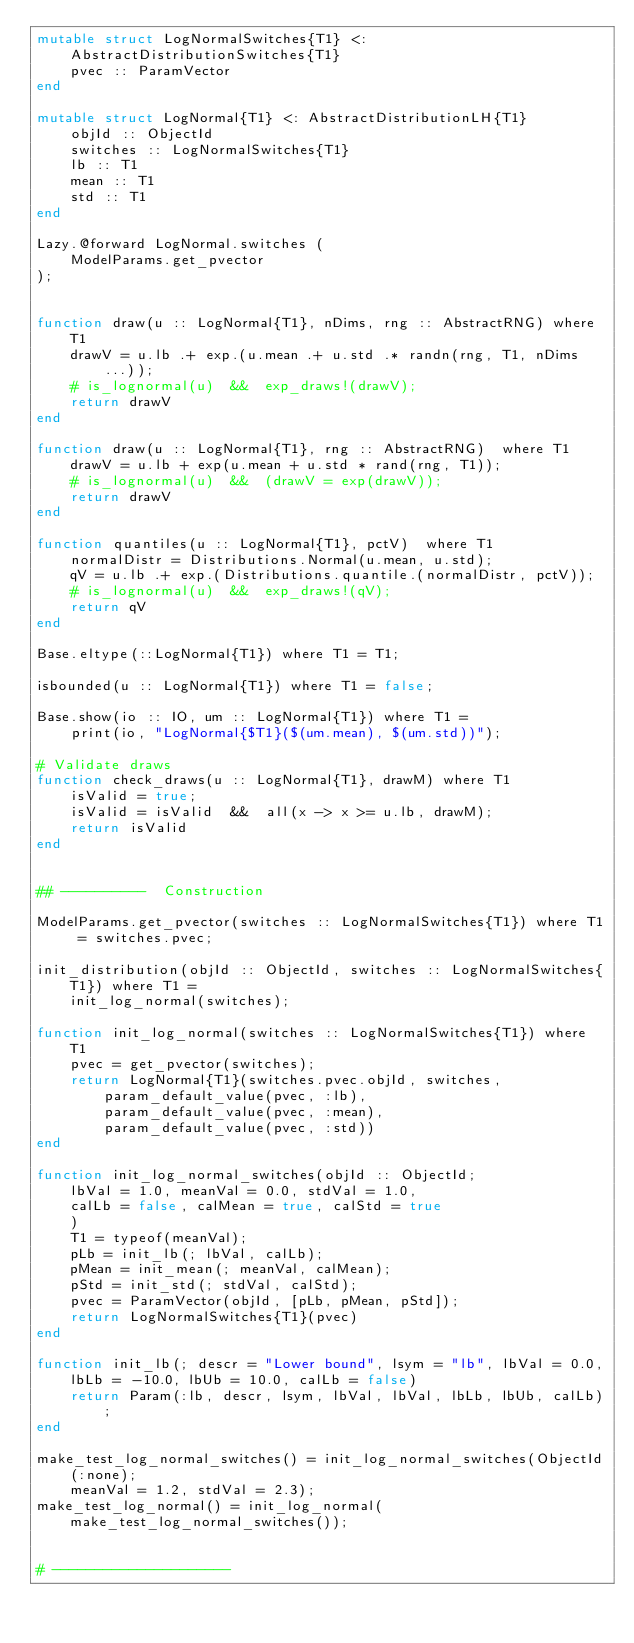<code> <loc_0><loc_0><loc_500><loc_500><_Julia_>mutable struct LogNormalSwitches{T1} <: AbstractDistributionSwitches{T1} 
    pvec :: ParamVector
end

mutable struct LogNormal{T1} <: AbstractDistributionLH{T1}
    objId :: ObjectId
    switches :: LogNormalSwitches{T1}
    lb :: T1
    mean :: T1
    std :: T1
end

Lazy.@forward LogNormal.switches (
    ModelParams.get_pvector
);


function draw(u :: LogNormal{T1}, nDims, rng :: AbstractRNG) where T1
    drawV = u.lb .+ exp.(u.mean .+ u.std .* randn(rng, T1, nDims...));
    # is_lognormal(u)  &&  exp_draws!(drawV);
    return drawV
end

function draw(u :: LogNormal{T1}, rng :: AbstractRNG)  where T1
    drawV = u.lb + exp(u.mean + u.std * rand(rng, T1));
    # is_lognormal(u)  &&  (drawV = exp(drawV));
    return drawV
end

function quantiles(u :: LogNormal{T1}, pctV)  where T1
    normalDistr = Distributions.Normal(u.mean, u.std);
    qV = u.lb .+ exp.(Distributions.quantile.(normalDistr, pctV));
    # is_lognormal(u)  &&  exp_draws!(qV);
    return qV
end

Base.eltype(::LogNormal{T1}) where T1 = T1;

isbounded(u :: LogNormal{T1}) where T1 = false;

Base.show(io :: IO, um :: LogNormal{T1}) where T1 = 
    print(io, "LogNormal{$T1}($(um.mean), $(um.std))");

# Validate draws
function check_draws(u :: LogNormal{T1}, drawM) where T1
    isValid = true;
    isValid = isValid  &&  all(x -> x >= u.lb, drawM);
    return isValid
end


## ----------  Construction

ModelParams.get_pvector(switches :: LogNormalSwitches{T1}) where T1 = switches.pvec;

init_distribution(objId :: ObjectId, switches :: LogNormalSwitches{T1}) where T1 = 
    init_log_normal(switches);

function init_log_normal(switches :: LogNormalSwitches{T1}) where T1
    pvec = get_pvector(switches);
    return LogNormal{T1}(switches.pvec.objId, switches, 
        param_default_value(pvec, :lb),
        param_default_value(pvec, :mean), 
        param_default_value(pvec, :std))
end

function init_log_normal_switches(objId :: ObjectId; 
    lbVal = 1.0, meanVal = 0.0, stdVal = 1.0, 
    calLb = false, calMean = true, calStd = true
    )
    T1 = typeof(meanVal);
    pLb = init_lb(; lbVal, calLb);
    pMean = init_mean(; meanVal, calMean);
    pStd = init_std(; stdVal, calStd);
    pvec = ParamVector(objId, [pLb, pMean, pStd]);
    return LogNormalSwitches{T1}(pvec)
end

function init_lb(; descr = "Lower bound", lsym = "lb", lbVal = 0.0,
    lbLb = -10.0, lbUb = 10.0, calLb = false)
    return Param(:lb, descr, lsym, lbVal, lbVal, lbLb, lbUb, calLb);
end

make_test_log_normal_switches() = init_log_normal_switches(ObjectId(:none);
    meanVal = 1.2, stdVal = 2.3); 
make_test_log_normal() = init_log_normal(make_test_log_normal_switches());


# ---------------------</code> 